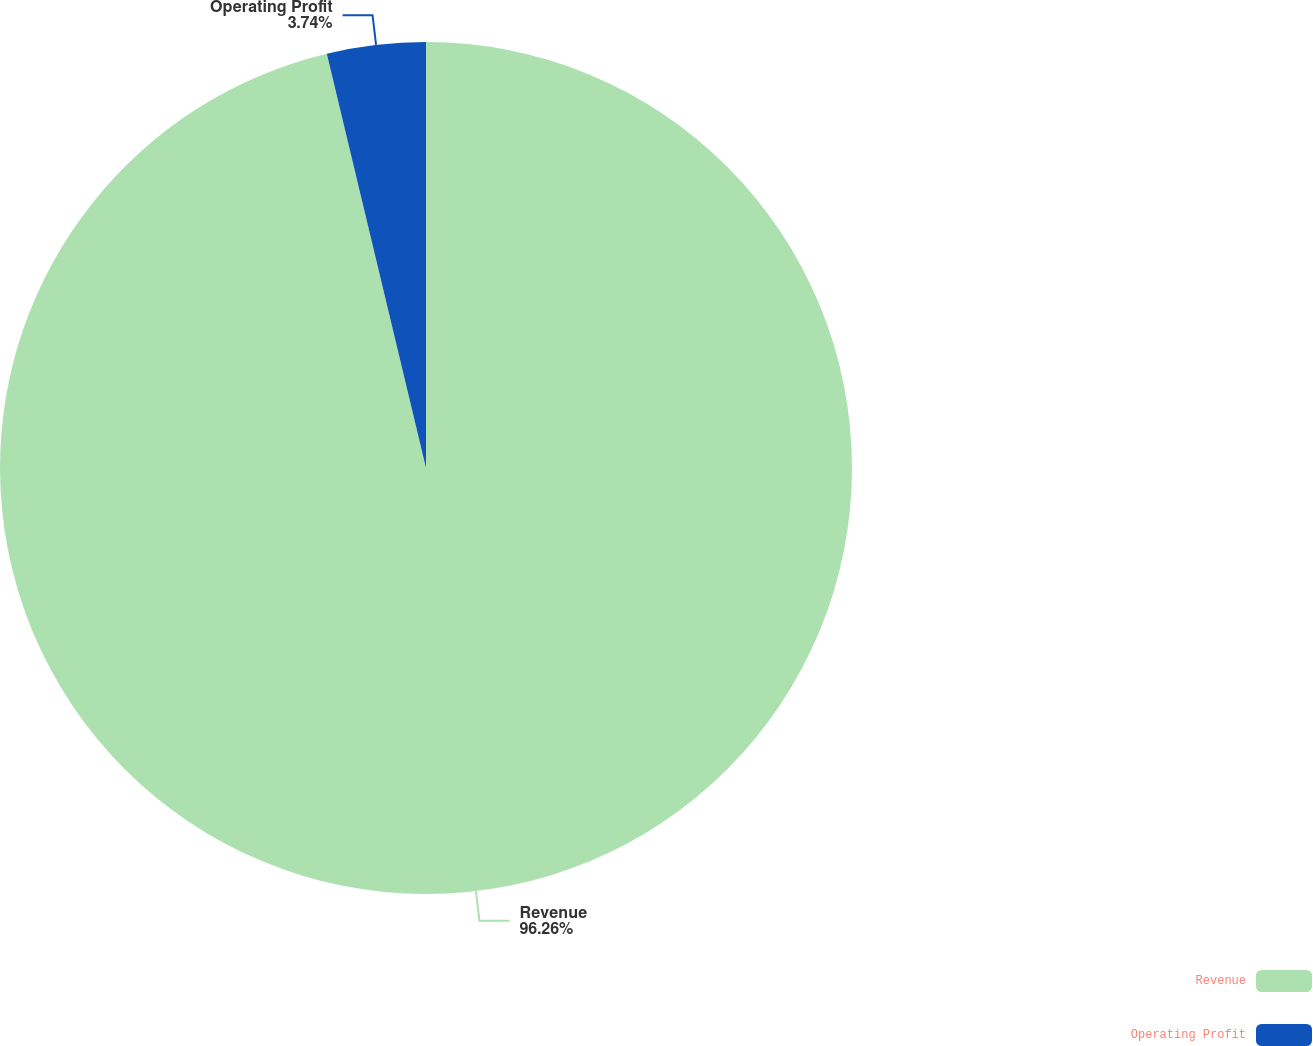Convert chart to OTSL. <chart><loc_0><loc_0><loc_500><loc_500><pie_chart><fcel>Revenue<fcel>Operating Profit<nl><fcel>96.26%<fcel>3.74%<nl></chart> 